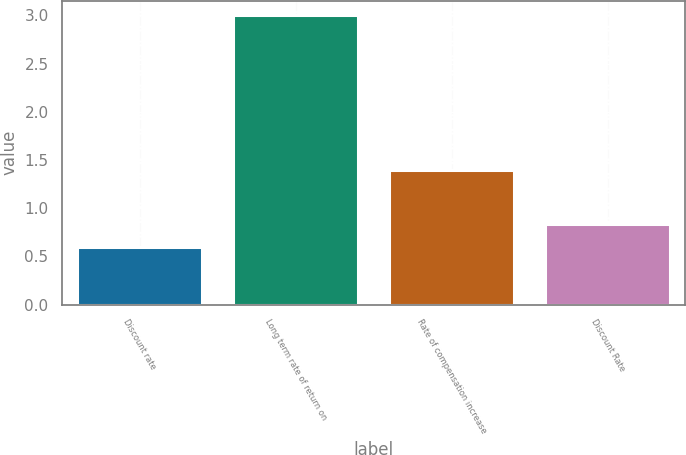Convert chart to OTSL. <chart><loc_0><loc_0><loc_500><loc_500><bar_chart><fcel>Discount rate<fcel>Long term rate of return on<fcel>Rate of compensation increase<fcel>Discount Rate<nl><fcel>0.6<fcel>3<fcel>1.4<fcel>0.84<nl></chart> 